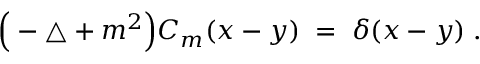Convert formula to latex. <formula><loc_0><loc_0><loc_500><loc_500>\left ( - \triangle + m ^ { 2 } \right ) C _ { m } ( x - y ) \, = \, \delta ( x - y ) \, .</formula> 